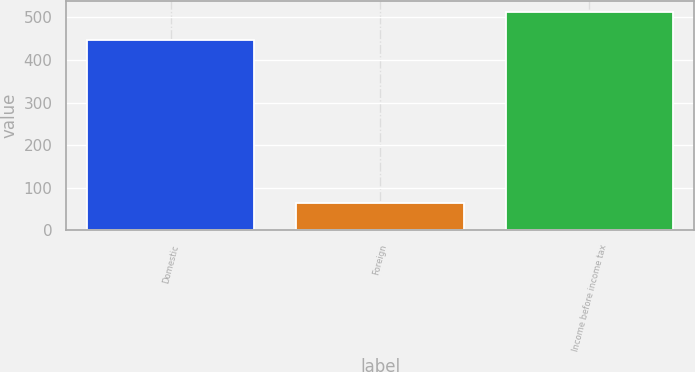Convert chart. <chart><loc_0><loc_0><loc_500><loc_500><bar_chart><fcel>Domestic<fcel>Foreign<fcel>Income before income tax<nl><fcel>448<fcel>65<fcel>513<nl></chart> 